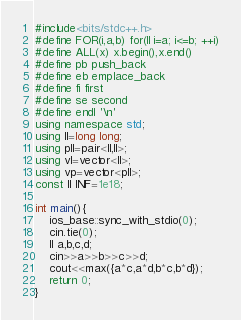<code> <loc_0><loc_0><loc_500><loc_500><_C++_>#include<bits/stdc++.h>
#define FOR(i,a,b) for(ll i=a; i<=b; ++i)
#define ALL(x) x.begin(),x.end()
#define pb push_back
#define eb emplace_back
#define fi first
#define se second
#define endl '\n'
using namespace std;
using ll=long long;
using pll=pair<ll,ll>;
using vl=vector<ll>;
using vp=vector<pll>;
const ll INF=1e18;

int main(){
    ios_base::sync_with_stdio(0);
    cin.tie(0);
    ll a,b,c,d;
    cin>>a>>b>>c>>d;
    cout<<max({a*c,a*d,b*c,b*d});
    return 0;
}</code> 